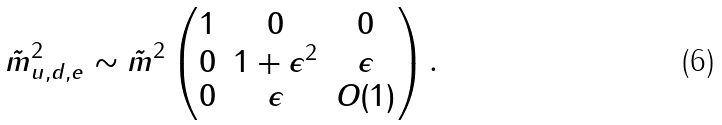Convert formula to latex. <formula><loc_0><loc_0><loc_500><loc_500>\tilde { m } ^ { 2 } _ { u , d , e } \sim \tilde { m } ^ { 2 } \left ( \begin{matrix} 1 & 0 & 0 \\ 0 & 1 + \epsilon ^ { 2 } & \epsilon \\ 0 & \epsilon & O ( 1 ) \end{matrix} \right ) .</formula> 